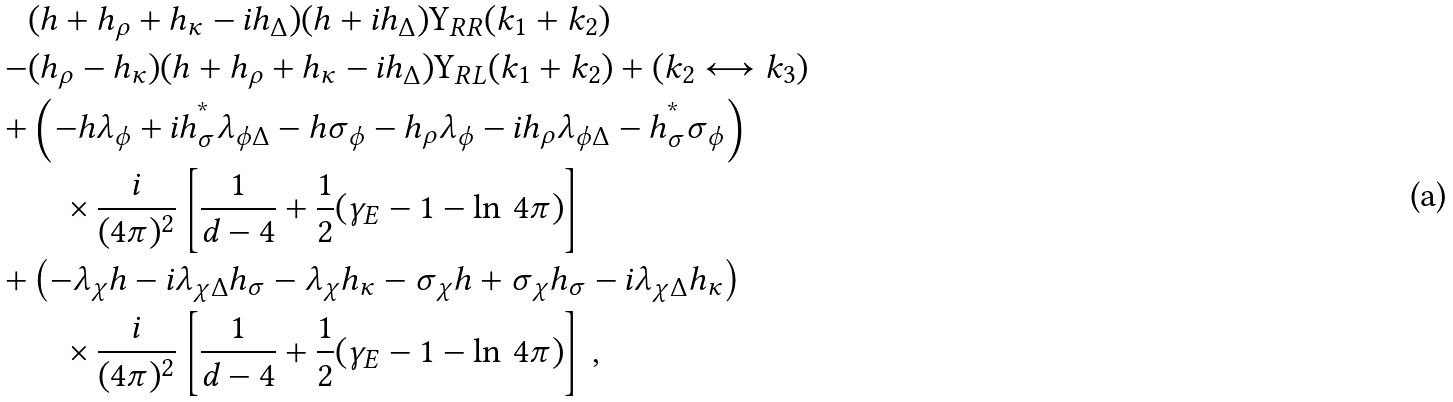<formula> <loc_0><loc_0><loc_500><loc_500>& ( h + h _ { \rho } + h _ { \kappa } - i h _ { \Delta } ) ( h + i h _ { \Delta } ) \Upsilon _ { R R } ( k _ { 1 } + k _ { 2 } ) \\ - & ( h _ { \rho } - h _ { \kappa } ) ( h + h _ { \rho } + h _ { \kappa } - i h _ { \Delta } ) \Upsilon _ { R L } ( k _ { 1 } + k _ { 2 } ) + ( k _ { 2 } \longleftrightarrow k _ { 3 } ) \\ + & \left ( - h \lambda _ { \phi } + i h _ { \sigma } ^ { ^ { * } } \lambda _ { \phi \Delta } - h \sigma _ { \phi } - h _ { \rho } \lambda _ { \phi } - i h _ { \rho } \lambda _ { \phi \Delta } - h _ { \sigma } ^ { ^ { * } } \sigma _ { \phi } \right ) \\ & \quad \times \frac { i } { ( 4 \pi ) ^ { 2 } } \left [ \frac { 1 } { d - 4 } + \frac { 1 } { 2 } ( \gamma _ { E } - 1 - \ln \, 4 \pi ) \right ] \\ + & \left ( - \lambda _ { \chi } h - i \lambda _ { \chi \Delta } h _ { \sigma } - \lambda _ { \chi } h _ { \kappa } - \sigma _ { \chi } h + \sigma _ { \chi } h _ { \sigma } - i \lambda _ { \chi \Delta } h _ { \kappa } \right ) \\ & \quad \times \frac { i } { ( 4 \pi ) ^ { 2 } } \left [ \frac { 1 } { d - 4 } + \frac { 1 } { 2 } ( \gamma _ { E } - 1 - \ln \, 4 \pi ) \right ] \, , \\</formula> 